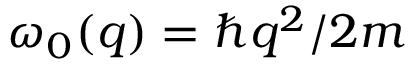Convert formula to latex. <formula><loc_0><loc_0><loc_500><loc_500>\omega _ { 0 } ( q ) = \hbar { q } ^ { 2 } / 2 m</formula> 